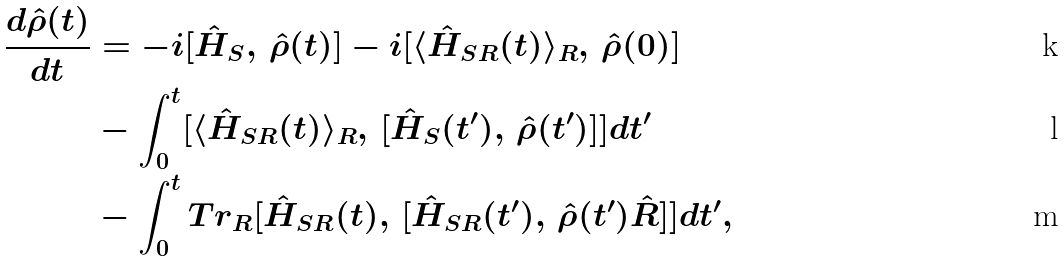Convert formula to latex. <formula><loc_0><loc_0><loc_500><loc_500>\frac { d \hat { \rho } ( t ) } { d t } & = - i [ \hat { H } _ { S } , \, \hat { \rho } ( t ) ] - i [ \langle \hat { H } _ { S R } ( t ) \rangle _ { R } , \, \hat { \rho } ( 0 ) ] \\ & - \int _ { 0 } ^ { t } [ \langle \hat { H } _ { S R } ( t ) \rangle _ { R } , \, [ \hat { H } _ { S } ( t ^ { \prime } ) , \, \hat { \rho } ( t ^ { \prime } ) ] ] d t ^ { \prime } \\ & - \int _ { 0 } ^ { t } T r _ { R } [ \hat { H } _ { S R } ( t ) , \, [ \hat { H } _ { S R } ( t ^ { \prime } ) , \, \hat { \rho } ( t ^ { \prime } ) \hat { R } ] ] d t ^ { \prime } ,</formula> 